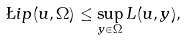Convert formula to latex. <formula><loc_0><loc_0><loc_500><loc_500>\L i p ( u , \Omega ) \leq \sup _ { y \in \Omega } L ( u , y ) ,</formula> 